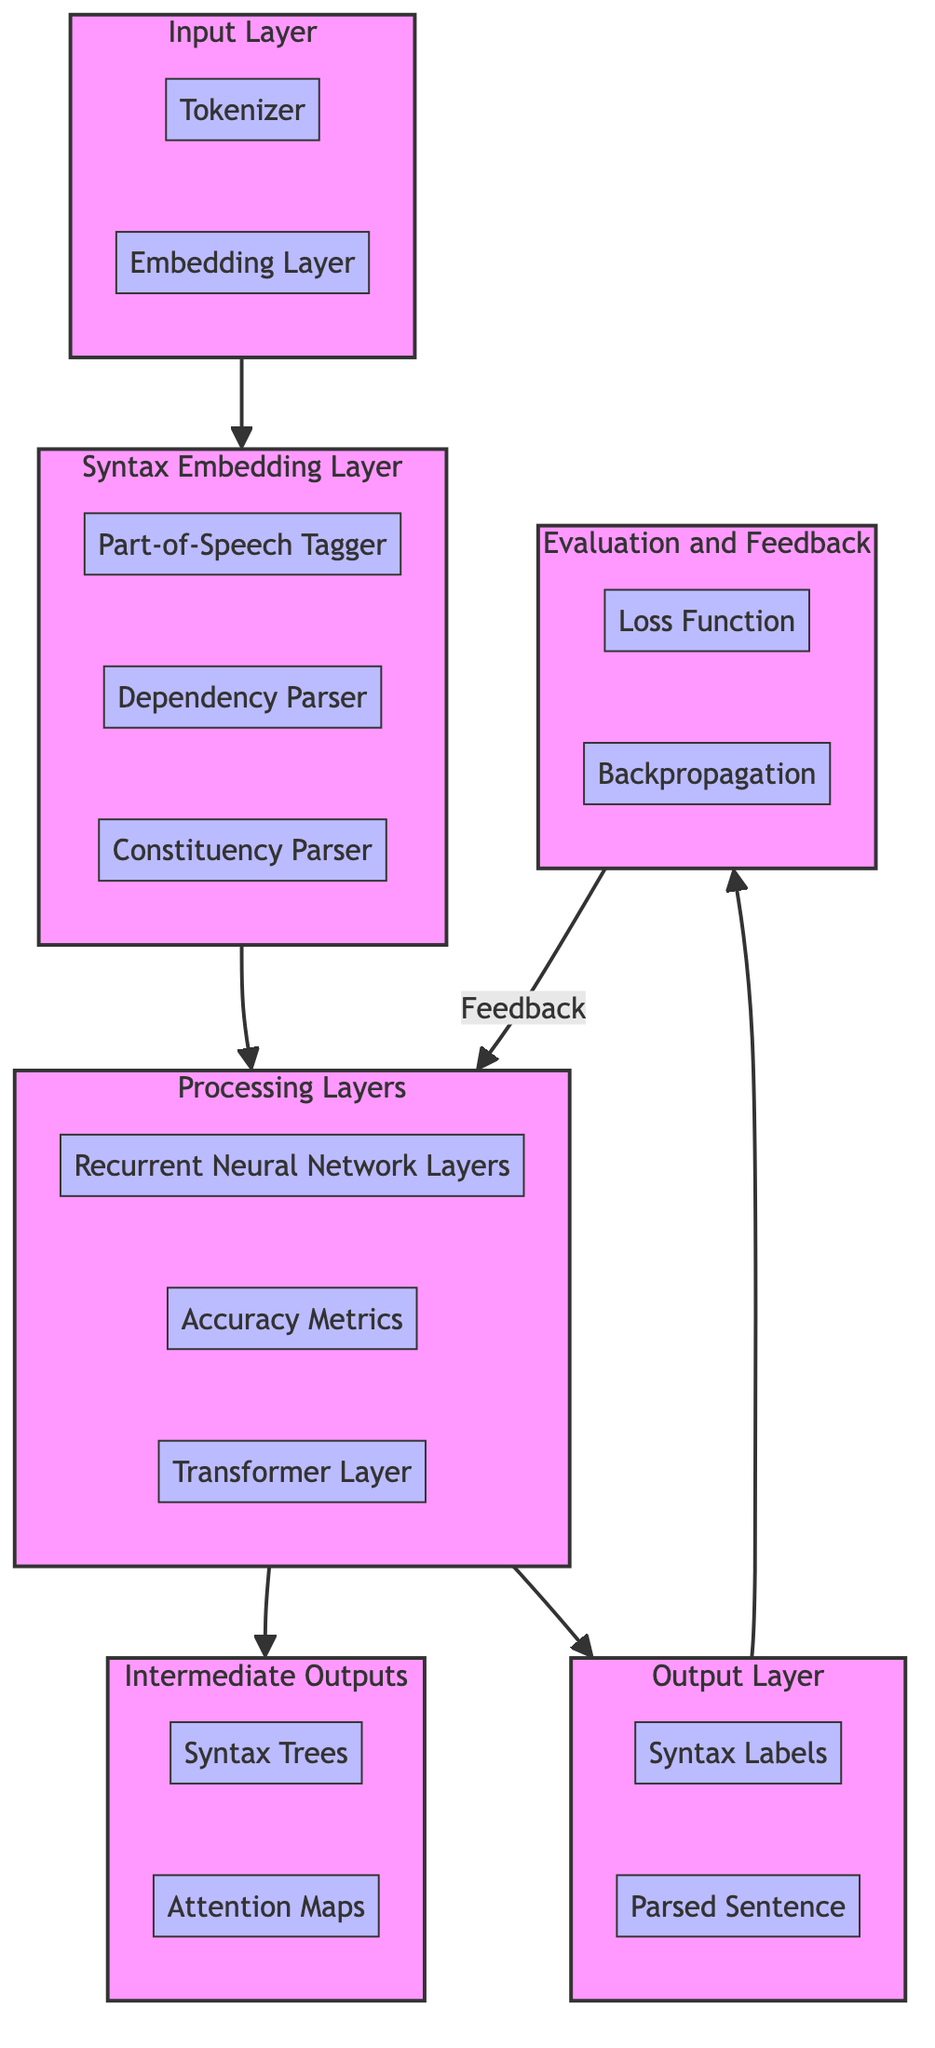What are the components of the Input Layer? The Input Layer consists of two components: Tokenizer and Embedding Layer. The diagram shows arrows connecting these components, indicating they are part of the Input Layer structure.
Answer: Tokenizer, Embedding Layer How many components are in the Syntax Embedding Layer? The Syntax Embedding Layer has three components: Part-of-Speech Tagger, Dependency Parser, and Constituency Parser. This can be counted from the diagram where the components are clustered under the Syntax Embedding Layer.
Answer: Three What is the output of the model as described in the Output Layer? The Output Layer produces two results: Syntax Labels and Parsed Sentence. Each of these components is depicted as outputs stemming from the structure, indicating they finalize the model's work.
Answer: Syntax Labels, Parsed Sentence Which processing mechanism follows the Recurrent Neural Network Layers? Following the Recurrent Neural Network Layers, the diagram shows an arrow leading to the Attention Mechanism, indicating this is the next step in the processing workflow.
Answer: Attention Mechanism What feedback mechanism is indicated in the Evaluation and Feedback layer? The backpropagation process is the feedback mechanism indicated, as the diagram shows an arrow leading from the Evaluation layer back to Processing, suggesting adjustments based on feedback are made here.
Answer: Backpropagation What is the primary function of the Syntax Trees in Intermediate Outputs? Syntax Trees in Intermediate Outputs serve to visualize the hierarchical structure of sentences. The description linked with this component clarifies its purpose, which is to represent sentence syntax visually.
Answer: Visualize structure How do the Evaluation and Feedback components interact with the Processing Layers? The Evaluation layer sends feedback to the Processing Layers through backpropagation, which is clearly shown by the arrow labeled Feedback in the diagram. This indicates an iterative relationship between evaluation and processing.
Answer: Backpropagation What role does the Attention Mechanism play in the Processing Layers? The Attention Mechanism enables the model to focus on relevant parts of the input sequence, which is highlighted in its description in the diagram, emphasizing its importance in distinguishing pertinent elements during processing.
Answer: Focus on relevant parts What is the relationship between the Intermediate Outputs and the Output Layer? The Intermediate Outputs provide data that informs the Output Layer, indicating that the outputs (like Syntax Labels and Parsed Sentence) may be influenced by the insights generated during earlier processing, leading to a structured final result.
Answer: Influenced by insights 